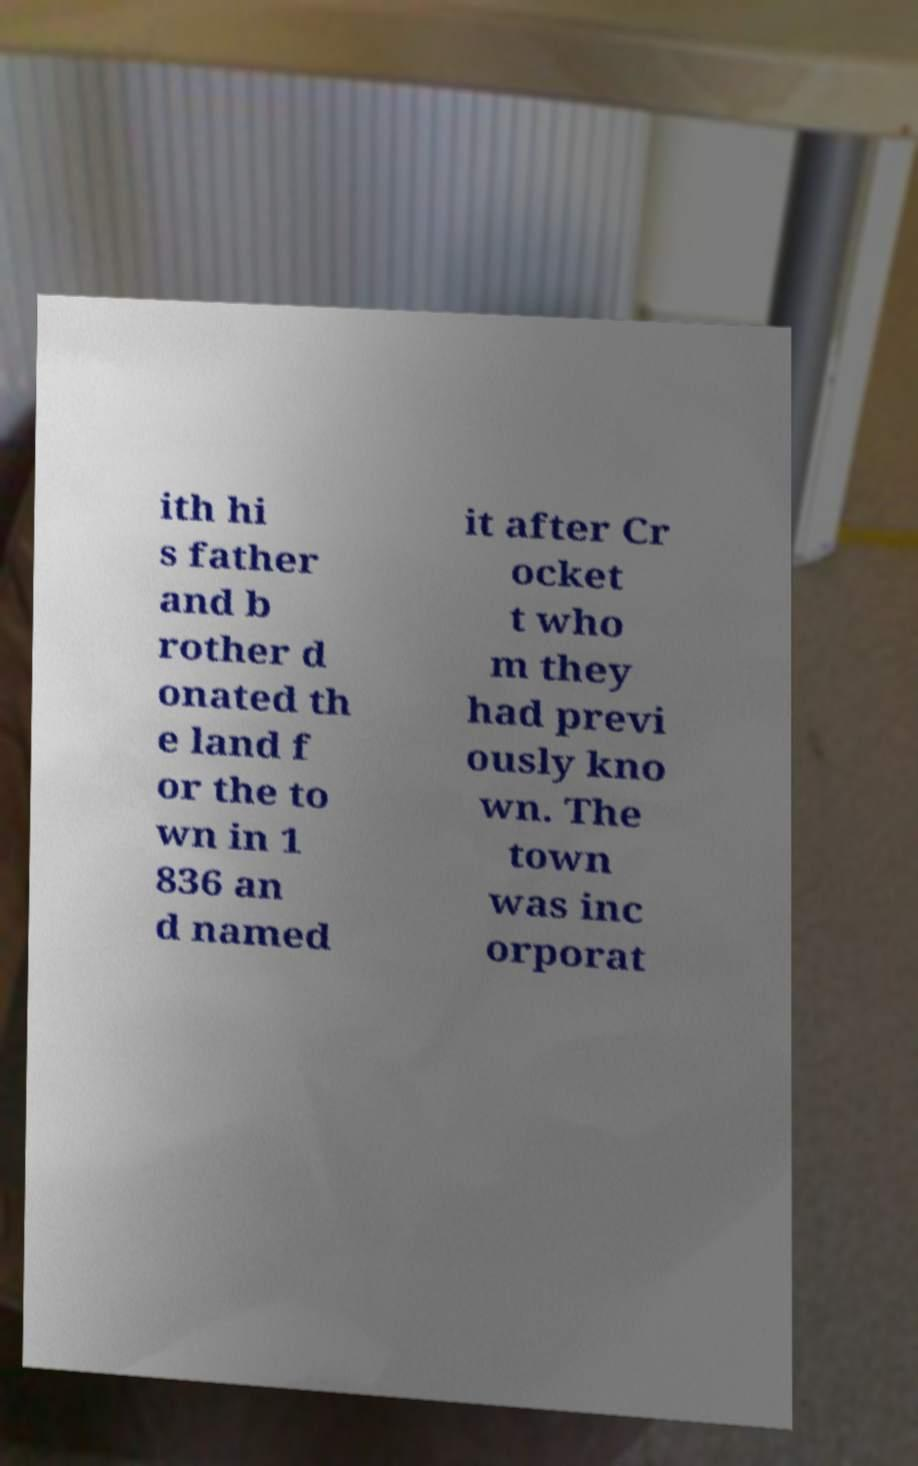What messages or text are displayed in this image? I need them in a readable, typed format. ith hi s father and b rother d onated th e land f or the to wn in 1 836 an d named it after Cr ocket t who m they had previ ously kno wn. The town was inc orporat 